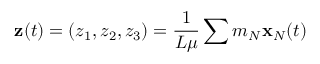Convert formula to latex. <formula><loc_0><loc_0><loc_500><loc_500>{ z } ( t ) = ( z _ { 1 } , z _ { 2 } , z _ { 3 } ) = \frac { 1 } { L \mu } \sum m _ { N } { x } _ { N } ( t )</formula> 